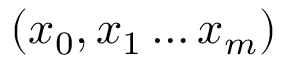<formula> <loc_0><loc_0><loc_500><loc_500>( x _ { 0 } , x _ { 1 } \dots x _ { m } )</formula> 